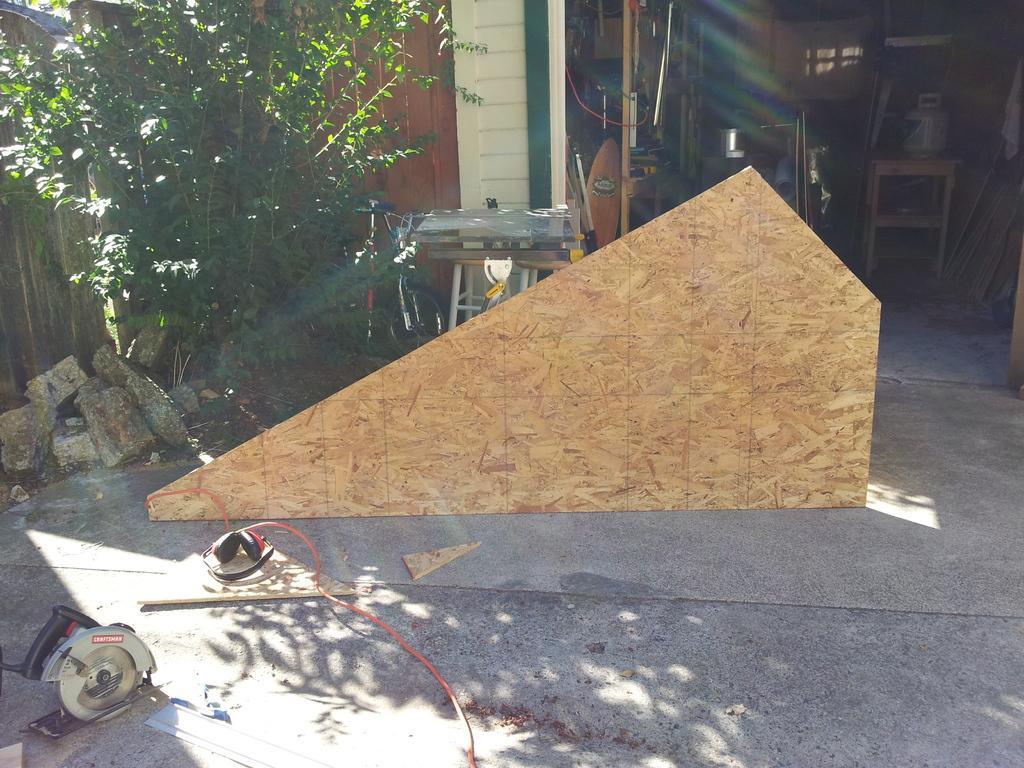Can you describe this image briefly? In this image there is a floor, on that floor there are machines and a wooden plank, in the background there is a plant and a shed, in that shed there are few objects. 